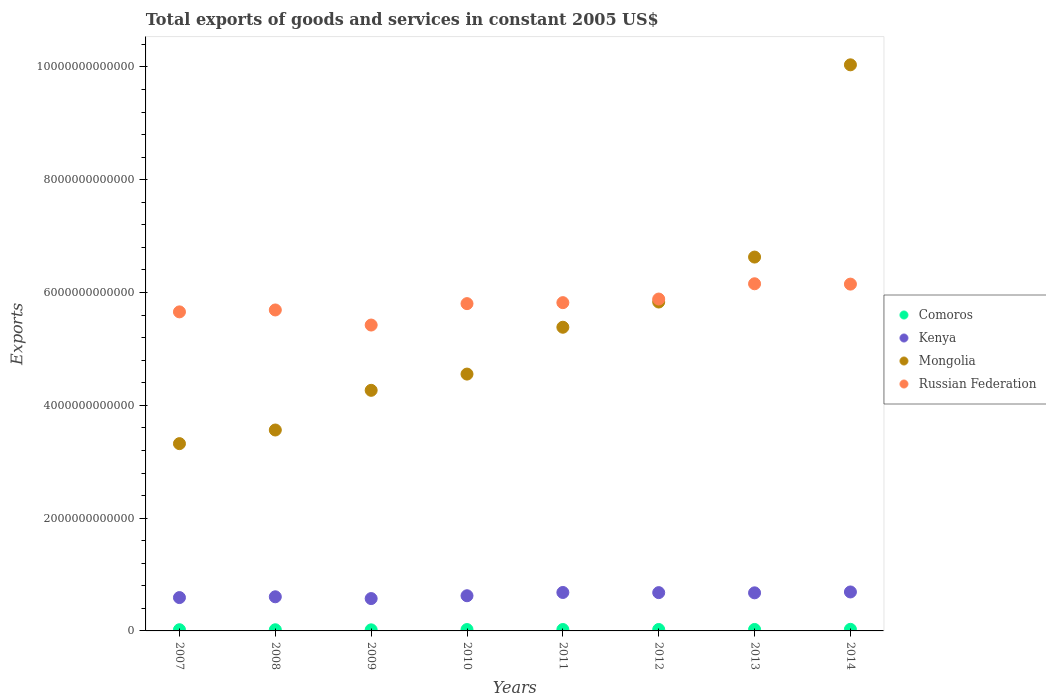What is the total exports of goods and services in Comoros in 2014?
Offer a very short reply. 2.82e+1. Across all years, what is the maximum total exports of goods and services in Comoros?
Provide a succinct answer. 2.82e+1. Across all years, what is the minimum total exports of goods and services in Mongolia?
Your response must be concise. 3.32e+12. What is the total total exports of goods and services in Kenya in the graph?
Offer a very short reply. 5.12e+12. What is the difference between the total exports of goods and services in Mongolia in 2009 and that in 2012?
Offer a very short reply. -1.57e+12. What is the difference between the total exports of goods and services in Kenya in 2008 and the total exports of goods and services in Comoros in 2009?
Keep it short and to the point. 5.86e+11. What is the average total exports of goods and services in Comoros per year?
Offer a very short reply. 2.37e+1. In the year 2010, what is the difference between the total exports of goods and services in Comoros and total exports of goods and services in Russian Federation?
Ensure brevity in your answer.  -5.78e+12. What is the ratio of the total exports of goods and services in Comoros in 2013 to that in 2014?
Your answer should be very brief. 0.92. Is the total exports of goods and services in Russian Federation in 2007 less than that in 2012?
Make the answer very short. Yes. Is the difference between the total exports of goods and services in Comoros in 2007 and 2013 greater than the difference between the total exports of goods and services in Russian Federation in 2007 and 2013?
Provide a succinct answer. Yes. What is the difference between the highest and the second highest total exports of goods and services in Kenya?
Your answer should be very brief. 9.18e+09. What is the difference between the highest and the lowest total exports of goods and services in Russian Federation?
Your response must be concise. 7.32e+11. In how many years, is the total exports of goods and services in Mongolia greater than the average total exports of goods and services in Mongolia taken over all years?
Your answer should be compact. 3. Is the sum of the total exports of goods and services in Mongolia in 2007 and 2014 greater than the maximum total exports of goods and services in Kenya across all years?
Keep it short and to the point. Yes. Is it the case that in every year, the sum of the total exports of goods and services in Kenya and total exports of goods and services in Mongolia  is greater than the total exports of goods and services in Comoros?
Make the answer very short. Yes. Is the total exports of goods and services in Mongolia strictly greater than the total exports of goods and services in Comoros over the years?
Provide a succinct answer. Yes. How many years are there in the graph?
Provide a succinct answer. 8. What is the difference between two consecutive major ticks on the Y-axis?
Offer a very short reply. 2.00e+12. Are the values on the major ticks of Y-axis written in scientific E-notation?
Make the answer very short. No. Does the graph contain grids?
Offer a terse response. No. What is the title of the graph?
Make the answer very short. Total exports of goods and services in constant 2005 US$. Does "Guinea-Bissau" appear as one of the legend labels in the graph?
Provide a short and direct response. No. What is the label or title of the X-axis?
Ensure brevity in your answer.  Years. What is the label or title of the Y-axis?
Keep it short and to the point. Exports. What is the Exports of Comoros in 2007?
Provide a short and direct response. 2.13e+1. What is the Exports of Kenya in 2007?
Your answer should be very brief. 5.91e+11. What is the Exports in Mongolia in 2007?
Give a very brief answer. 3.32e+12. What is the Exports in Russian Federation in 2007?
Your answer should be compact. 5.66e+12. What is the Exports in Comoros in 2008?
Give a very brief answer. 2.06e+1. What is the Exports in Kenya in 2008?
Provide a succinct answer. 6.05e+11. What is the Exports in Mongolia in 2008?
Your response must be concise. 3.56e+12. What is the Exports of Russian Federation in 2008?
Keep it short and to the point. 5.69e+12. What is the Exports in Comoros in 2009?
Give a very brief answer. 1.91e+1. What is the Exports in Kenya in 2009?
Make the answer very short. 5.74e+11. What is the Exports of Mongolia in 2009?
Provide a succinct answer. 4.27e+12. What is the Exports in Russian Federation in 2009?
Offer a terse response. 5.42e+12. What is the Exports of Comoros in 2010?
Your response must be concise. 2.44e+1. What is the Exports in Kenya in 2010?
Your answer should be compact. 6.24e+11. What is the Exports of Mongolia in 2010?
Give a very brief answer. 4.55e+12. What is the Exports of Russian Federation in 2010?
Give a very brief answer. 5.80e+12. What is the Exports of Comoros in 2011?
Ensure brevity in your answer.  2.48e+1. What is the Exports of Kenya in 2011?
Provide a succinct answer. 6.82e+11. What is the Exports in Mongolia in 2011?
Ensure brevity in your answer.  5.38e+12. What is the Exports of Russian Federation in 2011?
Your response must be concise. 5.82e+12. What is the Exports in Comoros in 2012?
Offer a very short reply. 2.53e+1. What is the Exports in Kenya in 2012?
Give a very brief answer. 6.79e+11. What is the Exports in Mongolia in 2012?
Keep it short and to the point. 5.83e+12. What is the Exports in Russian Federation in 2012?
Offer a very short reply. 5.88e+12. What is the Exports of Comoros in 2013?
Provide a succinct answer. 2.58e+1. What is the Exports of Kenya in 2013?
Make the answer very short. 6.75e+11. What is the Exports in Mongolia in 2013?
Your answer should be very brief. 6.63e+12. What is the Exports in Russian Federation in 2013?
Offer a terse response. 6.16e+12. What is the Exports in Comoros in 2014?
Offer a terse response. 2.82e+1. What is the Exports in Kenya in 2014?
Offer a very short reply. 6.91e+11. What is the Exports of Mongolia in 2014?
Provide a short and direct response. 1.00e+13. What is the Exports in Russian Federation in 2014?
Your answer should be compact. 6.15e+12. Across all years, what is the maximum Exports of Comoros?
Make the answer very short. 2.82e+1. Across all years, what is the maximum Exports in Kenya?
Your answer should be compact. 6.91e+11. Across all years, what is the maximum Exports of Mongolia?
Offer a terse response. 1.00e+13. Across all years, what is the maximum Exports in Russian Federation?
Your answer should be very brief. 6.16e+12. Across all years, what is the minimum Exports of Comoros?
Ensure brevity in your answer.  1.91e+1. Across all years, what is the minimum Exports in Kenya?
Provide a short and direct response. 5.74e+11. Across all years, what is the minimum Exports of Mongolia?
Your answer should be very brief. 3.32e+12. Across all years, what is the minimum Exports of Russian Federation?
Your answer should be very brief. 5.42e+12. What is the total Exports in Comoros in the graph?
Your answer should be compact. 1.90e+11. What is the total Exports of Kenya in the graph?
Your answer should be very brief. 5.12e+12. What is the total Exports in Mongolia in the graph?
Provide a short and direct response. 4.36e+13. What is the total Exports of Russian Federation in the graph?
Ensure brevity in your answer.  4.66e+13. What is the difference between the Exports of Comoros in 2007 and that in 2008?
Your answer should be very brief. 7.52e+08. What is the difference between the Exports of Kenya in 2007 and that in 2008?
Give a very brief answer. -1.40e+1. What is the difference between the Exports in Mongolia in 2007 and that in 2008?
Make the answer very short. -2.42e+11. What is the difference between the Exports of Russian Federation in 2007 and that in 2008?
Your answer should be very brief. -3.39e+1. What is the difference between the Exports of Comoros in 2007 and that in 2009?
Provide a succinct answer. 2.17e+09. What is the difference between the Exports of Kenya in 2007 and that in 2009?
Your response must be concise. 1.76e+1. What is the difference between the Exports in Mongolia in 2007 and that in 2009?
Your response must be concise. -9.45e+11. What is the difference between the Exports in Russian Federation in 2007 and that in 2009?
Your response must be concise. 2.34e+11. What is the difference between the Exports of Comoros in 2007 and that in 2010?
Keep it short and to the point. -3.05e+09. What is the difference between the Exports of Kenya in 2007 and that in 2010?
Provide a succinct answer. -3.26e+1. What is the difference between the Exports in Mongolia in 2007 and that in 2010?
Keep it short and to the point. -1.23e+12. What is the difference between the Exports in Russian Federation in 2007 and that in 2010?
Provide a short and direct response. -1.46e+11. What is the difference between the Exports of Comoros in 2007 and that in 2011?
Offer a terse response. -3.54e+09. What is the difference between the Exports in Kenya in 2007 and that in 2011?
Keep it short and to the point. -9.05e+1. What is the difference between the Exports in Mongolia in 2007 and that in 2011?
Offer a very short reply. -2.06e+12. What is the difference between the Exports of Russian Federation in 2007 and that in 2011?
Your answer should be very brief. -1.64e+11. What is the difference between the Exports in Comoros in 2007 and that in 2012?
Offer a very short reply. -4.03e+09. What is the difference between the Exports of Kenya in 2007 and that in 2012?
Make the answer very short. -8.78e+1. What is the difference between the Exports in Mongolia in 2007 and that in 2012?
Make the answer very short. -2.51e+12. What is the difference between the Exports of Russian Federation in 2007 and that in 2012?
Your response must be concise. -2.28e+11. What is the difference between the Exports in Comoros in 2007 and that in 2013?
Offer a very short reply. -4.54e+09. What is the difference between the Exports in Kenya in 2007 and that in 2013?
Your answer should be compact. -8.40e+1. What is the difference between the Exports in Mongolia in 2007 and that in 2013?
Give a very brief answer. -3.31e+12. What is the difference between the Exports of Russian Federation in 2007 and that in 2013?
Ensure brevity in your answer.  -4.98e+11. What is the difference between the Exports of Comoros in 2007 and that in 2014?
Provide a succinct answer. -6.87e+09. What is the difference between the Exports in Kenya in 2007 and that in 2014?
Offer a terse response. -9.97e+1. What is the difference between the Exports in Mongolia in 2007 and that in 2014?
Give a very brief answer. -6.72e+12. What is the difference between the Exports of Russian Federation in 2007 and that in 2014?
Offer a very short reply. -4.92e+11. What is the difference between the Exports of Comoros in 2008 and that in 2009?
Make the answer very short. 1.42e+09. What is the difference between the Exports in Kenya in 2008 and that in 2009?
Offer a very short reply. 3.16e+1. What is the difference between the Exports in Mongolia in 2008 and that in 2009?
Give a very brief answer. -7.04e+11. What is the difference between the Exports in Russian Federation in 2008 and that in 2009?
Make the answer very short. 2.67e+11. What is the difference between the Exports in Comoros in 2008 and that in 2010?
Keep it short and to the point. -3.80e+09. What is the difference between the Exports of Kenya in 2008 and that in 2010?
Your answer should be compact. -1.86e+1. What is the difference between the Exports in Mongolia in 2008 and that in 2010?
Your response must be concise. -9.92e+11. What is the difference between the Exports of Russian Federation in 2008 and that in 2010?
Provide a succinct answer. -1.12e+11. What is the difference between the Exports in Comoros in 2008 and that in 2011?
Provide a succinct answer. -4.29e+09. What is the difference between the Exports in Kenya in 2008 and that in 2011?
Your answer should be compact. -7.65e+1. What is the difference between the Exports of Mongolia in 2008 and that in 2011?
Provide a succinct answer. -1.82e+12. What is the difference between the Exports of Russian Federation in 2008 and that in 2011?
Provide a short and direct response. -1.30e+11. What is the difference between the Exports of Comoros in 2008 and that in 2012?
Ensure brevity in your answer.  -4.79e+09. What is the difference between the Exports of Kenya in 2008 and that in 2012?
Provide a short and direct response. -7.38e+1. What is the difference between the Exports of Mongolia in 2008 and that in 2012?
Offer a terse response. -2.27e+12. What is the difference between the Exports in Russian Federation in 2008 and that in 2012?
Provide a short and direct response. -1.94e+11. What is the difference between the Exports in Comoros in 2008 and that in 2013?
Keep it short and to the point. -5.29e+09. What is the difference between the Exports in Kenya in 2008 and that in 2013?
Keep it short and to the point. -7.00e+1. What is the difference between the Exports in Mongolia in 2008 and that in 2013?
Provide a short and direct response. -3.07e+12. What is the difference between the Exports of Russian Federation in 2008 and that in 2013?
Offer a very short reply. -4.64e+11. What is the difference between the Exports in Comoros in 2008 and that in 2014?
Your answer should be very brief. -7.62e+09. What is the difference between the Exports of Kenya in 2008 and that in 2014?
Offer a terse response. -8.56e+1. What is the difference between the Exports in Mongolia in 2008 and that in 2014?
Give a very brief answer. -6.48e+12. What is the difference between the Exports of Russian Federation in 2008 and that in 2014?
Your answer should be very brief. -4.58e+11. What is the difference between the Exports of Comoros in 2009 and that in 2010?
Make the answer very short. -5.22e+09. What is the difference between the Exports in Kenya in 2009 and that in 2010?
Give a very brief answer. -5.02e+1. What is the difference between the Exports of Mongolia in 2009 and that in 2010?
Provide a succinct answer. -2.88e+11. What is the difference between the Exports of Russian Federation in 2009 and that in 2010?
Your response must be concise. -3.80e+11. What is the difference between the Exports in Comoros in 2009 and that in 2011?
Provide a succinct answer. -5.71e+09. What is the difference between the Exports in Kenya in 2009 and that in 2011?
Give a very brief answer. -1.08e+11. What is the difference between the Exports of Mongolia in 2009 and that in 2011?
Your answer should be compact. -1.12e+12. What is the difference between the Exports of Russian Federation in 2009 and that in 2011?
Make the answer very short. -3.97e+11. What is the difference between the Exports in Comoros in 2009 and that in 2012?
Provide a succinct answer. -6.20e+09. What is the difference between the Exports of Kenya in 2009 and that in 2012?
Make the answer very short. -1.05e+11. What is the difference between the Exports of Mongolia in 2009 and that in 2012?
Offer a very short reply. -1.57e+12. What is the difference between the Exports of Russian Federation in 2009 and that in 2012?
Ensure brevity in your answer.  -4.61e+11. What is the difference between the Exports in Comoros in 2009 and that in 2013?
Ensure brevity in your answer.  -6.71e+09. What is the difference between the Exports in Kenya in 2009 and that in 2013?
Provide a succinct answer. -1.02e+11. What is the difference between the Exports in Mongolia in 2009 and that in 2013?
Your response must be concise. -2.36e+12. What is the difference between the Exports in Russian Federation in 2009 and that in 2013?
Ensure brevity in your answer.  -7.32e+11. What is the difference between the Exports in Comoros in 2009 and that in 2014?
Your answer should be very brief. -9.04e+09. What is the difference between the Exports of Kenya in 2009 and that in 2014?
Your answer should be very brief. -1.17e+11. What is the difference between the Exports of Mongolia in 2009 and that in 2014?
Offer a terse response. -5.77e+12. What is the difference between the Exports of Russian Federation in 2009 and that in 2014?
Offer a very short reply. -7.26e+11. What is the difference between the Exports in Comoros in 2010 and that in 2011?
Offer a terse response. -4.87e+08. What is the difference between the Exports in Kenya in 2010 and that in 2011?
Provide a short and direct response. -5.79e+1. What is the difference between the Exports of Mongolia in 2010 and that in 2011?
Provide a short and direct response. -8.30e+11. What is the difference between the Exports in Russian Federation in 2010 and that in 2011?
Offer a very short reply. -1.74e+1. What is the difference between the Exports in Comoros in 2010 and that in 2012?
Ensure brevity in your answer.  -9.84e+08. What is the difference between the Exports in Kenya in 2010 and that in 2012?
Provide a short and direct response. -5.52e+1. What is the difference between the Exports of Mongolia in 2010 and that in 2012?
Offer a terse response. -1.28e+12. What is the difference between the Exports of Russian Federation in 2010 and that in 2012?
Give a very brief answer. -8.14e+1. What is the difference between the Exports of Comoros in 2010 and that in 2013?
Your answer should be compact. -1.49e+09. What is the difference between the Exports in Kenya in 2010 and that in 2013?
Your answer should be very brief. -5.14e+1. What is the difference between the Exports in Mongolia in 2010 and that in 2013?
Provide a short and direct response. -2.07e+12. What is the difference between the Exports in Russian Federation in 2010 and that in 2013?
Your answer should be very brief. -3.52e+11. What is the difference between the Exports of Comoros in 2010 and that in 2014?
Provide a succinct answer. -3.82e+09. What is the difference between the Exports of Kenya in 2010 and that in 2014?
Offer a very short reply. -6.71e+1. What is the difference between the Exports in Mongolia in 2010 and that in 2014?
Offer a terse response. -5.48e+12. What is the difference between the Exports in Russian Federation in 2010 and that in 2014?
Your answer should be compact. -3.46e+11. What is the difference between the Exports in Comoros in 2011 and that in 2012?
Provide a short and direct response. -4.97e+08. What is the difference between the Exports in Kenya in 2011 and that in 2012?
Offer a very short reply. 2.67e+09. What is the difference between the Exports of Mongolia in 2011 and that in 2012?
Ensure brevity in your answer.  -4.47e+11. What is the difference between the Exports of Russian Federation in 2011 and that in 2012?
Your response must be concise. -6.40e+1. What is the difference between the Exports in Comoros in 2011 and that in 2013?
Ensure brevity in your answer.  -1.00e+09. What is the difference between the Exports in Kenya in 2011 and that in 2013?
Your response must be concise. 6.44e+09. What is the difference between the Exports of Mongolia in 2011 and that in 2013?
Offer a very short reply. -1.24e+12. What is the difference between the Exports of Russian Federation in 2011 and that in 2013?
Provide a succinct answer. -3.35e+11. What is the difference between the Exports of Comoros in 2011 and that in 2014?
Offer a very short reply. -3.33e+09. What is the difference between the Exports of Kenya in 2011 and that in 2014?
Keep it short and to the point. -9.18e+09. What is the difference between the Exports of Mongolia in 2011 and that in 2014?
Your response must be concise. -4.65e+12. What is the difference between the Exports of Russian Federation in 2011 and that in 2014?
Provide a short and direct response. -3.29e+11. What is the difference between the Exports in Comoros in 2012 and that in 2013?
Keep it short and to the point. -5.07e+08. What is the difference between the Exports of Kenya in 2012 and that in 2013?
Make the answer very short. 3.77e+09. What is the difference between the Exports in Mongolia in 2012 and that in 2013?
Your response must be concise. -7.97e+11. What is the difference between the Exports of Russian Federation in 2012 and that in 2013?
Offer a very short reply. -2.71e+11. What is the difference between the Exports in Comoros in 2012 and that in 2014?
Provide a short and direct response. -2.83e+09. What is the difference between the Exports in Kenya in 2012 and that in 2014?
Offer a very short reply. -1.18e+1. What is the difference between the Exports in Mongolia in 2012 and that in 2014?
Your answer should be compact. -4.21e+12. What is the difference between the Exports in Russian Federation in 2012 and that in 2014?
Ensure brevity in your answer.  -2.65e+11. What is the difference between the Exports in Comoros in 2013 and that in 2014?
Give a very brief answer. -2.33e+09. What is the difference between the Exports of Kenya in 2013 and that in 2014?
Your answer should be very brief. -1.56e+1. What is the difference between the Exports in Mongolia in 2013 and that in 2014?
Provide a short and direct response. -3.41e+12. What is the difference between the Exports in Russian Federation in 2013 and that in 2014?
Your answer should be compact. 6.16e+09. What is the difference between the Exports in Comoros in 2007 and the Exports in Kenya in 2008?
Make the answer very short. -5.84e+11. What is the difference between the Exports in Comoros in 2007 and the Exports in Mongolia in 2008?
Give a very brief answer. -3.54e+12. What is the difference between the Exports in Comoros in 2007 and the Exports in Russian Federation in 2008?
Keep it short and to the point. -5.67e+12. What is the difference between the Exports in Kenya in 2007 and the Exports in Mongolia in 2008?
Offer a terse response. -2.97e+12. What is the difference between the Exports of Kenya in 2007 and the Exports of Russian Federation in 2008?
Provide a short and direct response. -5.10e+12. What is the difference between the Exports in Mongolia in 2007 and the Exports in Russian Federation in 2008?
Offer a terse response. -2.37e+12. What is the difference between the Exports in Comoros in 2007 and the Exports in Kenya in 2009?
Make the answer very short. -5.52e+11. What is the difference between the Exports in Comoros in 2007 and the Exports in Mongolia in 2009?
Provide a short and direct response. -4.24e+12. What is the difference between the Exports of Comoros in 2007 and the Exports of Russian Federation in 2009?
Make the answer very short. -5.40e+12. What is the difference between the Exports in Kenya in 2007 and the Exports in Mongolia in 2009?
Make the answer very short. -3.68e+12. What is the difference between the Exports of Kenya in 2007 and the Exports of Russian Federation in 2009?
Give a very brief answer. -4.83e+12. What is the difference between the Exports in Mongolia in 2007 and the Exports in Russian Federation in 2009?
Offer a terse response. -2.10e+12. What is the difference between the Exports of Comoros in 2007 and the Exports of Kenya in 2010?
Your answer should be compact. -6.03e+11. What is the difference between the Exports in Comoros in 2007 and the Exports in Mongolia in 2010?
Give a very brief answer. -4.53e+12. What is the difference between the Exports of Comoros in 2007 and the Exports of Russian Federation in 2010?
Your answer should be compact. -5.78e+12. What is the difference between the Exports in Kenya in 2007 and the Exports in Mongolia in 2010?
Offer a terse response. -3.96e+12. What is the difference between the Exports of Kenya in 2007 and the Exports of Russian Federation in 2010?
Offer a very short reply. -5.21e+12. What is the difference between the Exports of Mongolia in 2007 and the Exports of Russian Federation in 2010?
Your answer should be very brief. -2.48e+12. What is the difference between the Exports in Comoros in 2007 and the Exports in Kenya in 2011?
Your answer should be very brief. -6.60e+11. What is the difference between the Exports in Comoros in 2007 and the Exports in Mongolia in 2011?
Provide a succinct answer. -5.36e+12. What is the difference between the Exports of Comoros in 2007 and the Exports of Russian Federation in 2011?
Provide a succinct answer. -5.80e+12. What is the difference between the Exports in Kenya in 2007 and the Exports in Mongolia in 2011?
Keep it short and to the point. -4.79e+12. What is the difference between the Exports in Kenya in 2007 and the Exports in Russian Federation in 2011?
Your answer should be very brief. -5.23e+12. What is the difference between the Exports in Mongolia in 2007 and the Exports in Russian Federation in 2011?
Provide a short and direct response. -2.50e+12. What is the difference between the Exports of Comoros in 2007 and the Exports of Kenya in 2012?
Make the answer very short. -6.58e+11. What is the difference between the Exports of Comoros in 2007 and the Exports of Mongolia in 2012?
Your answer should be compact. -5.81e+12. What is the difference between the Exports in Comoros in 2007 and the Exports in Russian Federation in 2012?
Make the answer very short. -5.86e+12. What is the difference between the Exports in Kenya in 2007 and the Exports in Mongolia in 2012?
Your answer should be compact. -5.24e+12. What is the difference between the Exports in Kenya in 2007 and the Exports in Russian Federation in 2012?
Offer a terse response. -5.29e+12. What is the difference between the Exports in Mongolia in 2007 and the Exports in Russian Federation in 2012?
Your answer should be very brief. -2.56e+12. What is the difference between the Exports in Comoros in 2007 and the Exports in Kenya in 2013?
Your answer should be compact. -6.54e+11. What is the difference between the Exports of Comoros in 2007 and the Exports of Mongolia in 2013?
Your answer should be compact. -6.61e+12. What is the difference between the Exports in Comoros in 2007 and the Exports in Russian Federation in 2013?
Your answer should be very brief. -6.13e+12. What is the difference between the Exports of Kenya in 2007 and the Exports of Mongolia in 2013?
Your answer should be very brief. -6.04e+12. What is the difference between the Exports of Kenya in 2007 and the Exports of Russian Federation in 2013?
Your answer should be compact. -5.56e+12. What is the difference between the Exports of Mongolia in 2007 and the Exports of Russian Federation in 2013?
Your response must be concise. -2.83e+12. What is the difference between the Exports of Comoros in 2007 and the Exports of Kenya in 2014?
Ensure brevity in your answer.  -6.70e+11. What is the difference between the Exports in Comoros in 2007 and the Exports in Mongolia in 2014?
Offer a terse response. -1.00e+13. What is the difference between the Exports in Comoros in 2007 and the Exports in Russian Federation in 2014?
Your answer should be compact. -6.13e+12. What is the difference between the Exports in Kenya in 2007 and the Exports in Mongolia in 2014?
Your answer should be very brief. -9.45e+12. What is the difference between the Exports of Kenya in 2007 and the Exports of Russian Federation in 2014?
Your answer should be compact. -5.56e+12. What is the difference between the Exports of Mongolia in 2007 and the Exports of Russian Federation in 2014?
Your answer should be compact. -2.83e+12. What is the difference between the Exports of Comoros in 2008 and the Exports of Kenya in 2009?
Give a very brief answer. -5.53e+11. What is the difference between the Exports of Comoros in 2008 and the Exports of Mongolia in 2009?
Your response must be concise. -4.25e+12. What is the difference between the Exports in Comoros in 2008 and the Exports in Russian Federation in 2009?
Ensure brevity in your answer.  -5.40e+12. What is the difference between the Exports of Kenya in 2008 and the Exports of Mongolia in 2009?
Make the answer very short. -3.66e+12. What is the difference between the Exports of Kenya in 2008 and the Exports of Russian Federation in 2009?
Ensure brevity in your answer.  -4.82e+12. What is the difference between the Exports of Mongolia in 2008 and the Exports of Russian Federation in 2009?
Keep it short and to the point. -1.86e+12. What is the difference between the Exports in Comoros in 2008 and the Exports in Kenya in 2010?
Ensure brevity in your answer.  -6.03e+11. What is the difference between the Exports in Comoros in 2008 and the Exports in Mongolia in 2010?
Your answer should be compact. -4.53e+12. What is the difference between the Exports of Comoros in 2008 and the Exports of Russian Federation in 2010?
Provide a succinct answer. -5.78e+12. What is the difference between the Exports in Kenya in 2008 and the Exports in Mongolia in 2010?
Your response must be concise. -3.95e+12. What is the difference between the Exports in Kenya in 2008 and the Exports in Russian Federation in 2010?
Your answer should be very brief. -5.20e+12. What is the difference between the Exports in Mongolia in 2008 and the Exports in Russian Federation in 2010?
Offer a very short reply. -2.24e+12. What is the difference between the Exports in Comoros in 2008 and the Exports in Kenya in 2011?
Give a very brief answer. -6.61e+11. What is the difference between the Exports in Comoros in 2008 and the Exports in Mongolia in 2011?
Provide a short and direct response. -5.36e+12. What is the difference between the Exports of Comoros in 2008 and the Exports of Russian Federation in 2011?
Your answer should be compact. -5.80e+12. What is the difference between the Exports of Kenya in 2008 and the Exports of Mongolia in 2011?
Ensure brevity in your answer.  -4.78e+12. What is the difference between the Exports of Kenya in 2008 and the Exports of Russian Federation in 2011?
Keep it short and to the point. -5.22e+12. What is the difference between the Exports in Mongolia in 2008 and the Exports in Russian Federation in 2011?
Make the answer very short. -2.26e+12. What is the difference between the Exports of Comoros in 2008 and the Exports of Kenya in 2012?
Ensure brevity in your answer.  -6.58e+11. What is the difference between the Exports in Comoros in 2008 and the Exports in Mongolia in 2012?
Ensure brevity in your answer.  -5.81e+12. What is the difference between the Exports of Comoros in 2008 and the Exports of Russian Federation in 2012?
Keep it short and to the point. -5.86e+12. What is the difference between the Exports in Kenya in 2008 and the Exports in Mongolia in 2012?
Offer a very short reply. -5.23e+12. What is the difference between the Exports in Kenya in 2008 and the Exports in Russian Federation in 2012?
Your answer should be very brief. -5.28e+12. What is the difference between the Exports of Mongolia in 2008 and the Exports of Russian Federation in 2012?
Your answer should be compact. -2.32e+12. What is the difference between the Exports of Comoros in 2008 and the Exports of Kenya in 2013?
Provide a succinct answer. -6.55e+11. What is the difference between the Exports of Comoros in 2008 and the Exports of Mongolia in 2013?
Your response must be concise. -6.61e+12. What is the difference between the Exports in Comoros in 2008 and the Exports in Russian Federation in 2013?
Give a very brief answer. -6.14e+12. What is the difference between the Exports in Kenya in 2008 and the Exports in Mongolia in 2013?
Make the answer very short. -6.02e+12. What is the difference between the Exports of Kenya in 2008 and the Exports of Russian Federation in 2013?
Provide a short and direct response. -5.55e+12. What is the difference between the Exports in Mongolia in 2008 and the Exports in Russian Federation in 2013?
Your answer should be compact. -2.59e+12. What is the difference between the Exports in Comoros in 2008 and the Exports in Kenya in 2014?
Give a very brief answer. -6.70e+11. What is the difference between the Exports of Comoros in 2008 and the Exports of Mongolia in 2014?
Your answer should be very brief. -1.00e+13. What is the difference between the Exports of Comoros in 2008 and the Exports of Russian Federation in 2014?
Your response must be concise. -6.13e+12. What is the difference between the Exports in Kenya in 2008 and the Exports in Mongolia in 2014?
Provide a succinct answer. -9.43e+12. What is the difference between the Exports in Kenya in 2008 and the Exports in Russian Federation in 2014?
Provide a succinct answer. -5.54e+12. What is the difference between the Exports of Mongolia in 2008 and the Exports of Russian Federation in 2014?
Make the answer very short. -2.59e+12. What is the difference between the Exports in Comoros in 2009 and the Exports in Kenya in 2010?
Your answer should be compact. -6.05e+11. What is the difference between the Exports of Comoros in 2009 and the Exports of Mongolia in 2010?
Give a very brief answer. -4.54e+12. What is the difference between the Exports in Comoros in 2009 and the Exports in Russian Federation in 2010?
Give a very brief answer. -5.78e+12. What is the difference between the Exports in Kenya in 2009 and the Exports in Mongolia in 2010?
Offer a very short reply. -3.98e+12. What is the difference between the Exports in Kenya in 2009 and the Exports in Russian Federation in 2010?
Give a very brief answer. -5.23e+12. What is the difference between the Exports in Mongolia in 2009 and the Exports in Russian Federation in 2010?
Your answer should be compact. -1.54e+12. What is the difference between the Exports in Comoros in 2009 and the Exports in Kenya in 2011?
Your response must be concise. -6.63e+11. What is the difference between the Exports in Comoros in 2009 and the Exports in Mongolia in 2011?
Your answer should be very brief. -5.37e+12. What is the difference between the Exports of Comoros in 2009 and the Exports of Russian Federation in 2011?
Ensure brevity in your answer.  -5.80e+12. What is the difference between the Exports in Kenya in 2009 and the Exports in Mongolia in 2011?
Provide a short and direct response. -4.81e+12. What is the difference between the Exports in Kenya in 2009 and the Exports in Russian Federation in 2011?
Offer a very short reply. -5.25e+12. What is the difference between the Exports of Mongolia in 2009 and the Exports of Russian Federation in 2011?
Your answer should be very brief. -1.55e+12. What is the difference between the Exports in Comoros in 2009 and the Exports in Kenya in 2012?
Offer a very short reply. -6.60e+11. What is the difference between the Exports of Comoros in 2009 and the Exports of Mongolia in 2012?
Keep it short and to the point. -5.81e+12. What is the difference between the Exports in Comoros in 2009 and the Exports in Russian Federation in 2012?
Your answer should be very brief. -5.87e+12. What is the difference between the Exports of Kenya in 2009 and the Exports of Mongolia in 2012?
Provide a succinct answer. -5.26e+12. What is the difference between the Exports of Kenya in 2009 and the Exports of Russian Federation in 2012?
Your response must be concise. -5.31e+12. What is the difference between the Exports of Mongolia in 2009 and the Exports of Russian Federation in 2012?
Your answer should be compact. -1.62e+12. What is the difference between the Exports in Comoros in 2009 and the Exports in Kenya in 2013?
Ensure brevity in your answer.  -6.56e+11. What is the difference between the Exports in Comoros in 2009 and the Exports in Mongolia in 2013?
Your answer should be compact. -6.61e+12. What is the difference between the Exports in Comoros in 2009 and the Exports in Russian Federation in 2013?
Provide a short and direct response. -6.14e+12. What is the difference between the Exports in Kenya in 2009 and the Exports in Mongolia in 2013?
Offer a very short reply. -6.06e+12. What is the difference between the Exports of Kenya in 2009 and the Exports of Russian Federation in 2013?
Ensure brevity in your answer.  -5.58e+12. What is the difference between the Exports of Mongolia in 2009 and the Exports of Russian Federation in 2013?
Your response must be concise. -1.89e+12. What is the difference between the Exports in Comoros in 2009 and the Exports in Kenya in 2014?
Provide a short and direct response. -6.72e+11. What is the difference between the Exports of Comoros in 2009 and the Exports of Mongolia in 2014?
Provide a succinct answer. -1.00e+13. What is the difference between the Exports of Comoros in 2009 and the Exports of Russian Federation in 2014?
Your response must be concise. -6.13e+12. What is the difference between the Exports of Kenya in 2009 and the Exports of Mongolia in 2014?
Ensure brevity in your answer.  -9.46e+12. What is the difference between the Exports in Kenya in 2009 and the Exports in Russian Federation in 2014?
Provide a short and direct response. -5.58e+12. What is the difference between the Exports of Mongolia in 2009 and the Exports of Russian Federation in 2014?
Your response must be concise. -1.88e+12. What is the difference between the Exports of Comoros in 2010 and the Exports of Kenya in 2011?
Your response must be concise. -6.57e+11. What is the difference between the Exports of Comoros in 2010 and the Exports of Mongolia in 2011?
Provide a short and direct response. -5.36e+12. What is the difference between the Exports of Comoros in 2010 and the Exports of Russian Federation in 2011?
Your response must be concise. -5.80e+12. What is the difference between the Exports of Kenya in 2010 and the Exports of Mongolia in 2011?
Offer a terse response. -4.76e+12. What is the difference between the Exports of Kenya in 2010 and the Exports of Russian Federation in 2011?
Ensure brevity in your answer.  -5.20e+12. What is the difference between the Exports in Mongolia in 2010 and the Exports in Russian Federation in 2011?
Your response must be concise. -1.27e+12. What is the difference between the Exports of Comoros in 2010 and the Exports of Kenya in 2012?
Offer a very short reply. -6.55e+11. What is the difference between the Exports of Comoros in 2010 and the Exports of Mongolia in 2012?
Make the answer very short. -5.81e+12. What is the difference between the Exports in Comoros in 2010 and the Exports in Russian Federation in 2012?
Provide a short and direct response. -5.86e+12. What is the difference between the Exports of Kenya in 2010 and the Exports of Mongolia in 2012?
Give a very brief answer. -5.21e+12. What is the difference between the Exports of Kenya in 2010 and the Exports of Russian Federation in 2012?
Your answer should be very brief. -5.26e+12. What is the difference between the Exports in Mongolia in 2010 and the Exports in Russian Federation in 2012?
Give a very brief answer. -1.33e+12. What is the difference between the Exports in Comoros in 2010 and the Exports in Kenya in 2013?
Your response must be concise. -6.51e+11. What is the difference between the Exports of Comoros in 2010 and the Exports of Mongolia in 2013?
Offer a very short reply. -6.60e+12. What is the difference between the Exports of Comoros in 2010 and the Exports of Russian Federation in 2013?
Your answer should be very brief. -6.13e+12. What is the difference between the Exports in Kenya in 2010 and the Exports in Mongolia in 2013?
Your answer should be compact. -6.01e+12. What is the difference between the Exports of Kenya in 2010 and the Exports of Russian Federation in 2013?
Provide a succinct answer. -5.53e+12. What is the difference between the Exports of Mongolia in 2010 and the Exports of Russian Federation in 2013?
Provide a short and direct response. -1.60e+12. What is the difference between the Exports of Comoros in 2010 and the Exports of Kenya in 2014?
Make the answer very short. -6.67e+11. What is the difference between the Exports of Comoros in 2010 and the Exports of Mongolia in 2014?
Offer a very short reply. -1.00e+13. What is the difference between the Exports of Comoros in 2010 and the Exports of Russian Federation in 2014?
Your answer should be very brief. -6.13e+12. What is the difference between the Exports of Kenya in 2010 and the Exports of Mongolia in 2014?
Ensure brevity in your answer.  -9.41e+12. What is the difference between the Exports in Kenya in 2010 and the Exports in Russian Federation in 2014?
Make the answer very short. -5.53e+12. What is the difference between the Exports in Mongolia in 2010 and the Exports in Russian Federation in 2014?
Give a very brief answer. -1.60e+12. What is the difference between the Exports of Comoros in 2011 and the Exports of Kenya in 2012?
Ensure brevity in your answer.  -6.54e+11. What is the difference between the Exports of Comoros in 2011 and the Exports of Mongolia in 2012?
Ensure brevity in your answer.  -5.81e+12. What is the difference between the Exports of Comoros in 2011 and the Exports of Russian Federation in 2012?
Provide a succinct answer. -5.86e+12. What is the difference between the Exports in Kenya in 2011 and the Exports in Mongolia in 2012?
Your answer should be compact. -5.15e+12. What is the difference between the Exports in Kenya in 2011 and the Exports in Russian Federation in 2012?
Give a very brief answer. -5.20e+12. What is the difference between the Exports of Mongolia in 2011 and the Exports of Russian Federation in 2012?
Ensure brevity in your answer.  -5.00e+11. What is the difference between the Exports of Comoros in 2011 and the Exports of Kenya in 2013?
Your answer should be compact. -6.50e+11. What is the difference between the Exports in Comoros in 2011 and the Exports in Mongolia in 2013?
Give a very brief answer. -6.60e+12. What is the difference between the Exports of Comoros in 2011 and the Exports of Russian Federation in 2013?
Ensure brevity in your answer.  -6.13e+12. What is the difference between the Exports in Kenya in 2011 and the Exports in Mongolia in 2013?
Give a very brief answer. -5.95e+12. What is the difference between the Exports in Kenya in 2011 and the Exports in Russian Federation in 2013?
Provide a short and direct response. -5.47e+12. What is the difference between the Exports in Mongolia in 2011 and the Exports in Russian Federation in 2013?
Give a very brief answer. -7.71e+11. What is the difference between the Exports of Comoros in 2011 and the Exports of Kenya in 2014?
Ensure brevity in your answer.  -6.66e+11. What is the difference between the Exports in Comoros in 2011 and the Exports in Mongolia in 2014?
Give a very brief answer. -1.00e+13. What is the difference between the Exports in Comoros in 2011 and the Exports in Russian Federation in 2014?
Make the answer very short. -6.12e+12. What is the difference between the Exports in Kenya in 2011 and the Exports in Mongolia in 2014?
Your answer should be very brief. -9.36e+12. What is the difference between the Exports in Kenya in 2011 and the Exports in Russian Federation in 2014?
Your answer should be compact. -5.47e+12. What is the difference between the Exports in Mongolia in 2011 and the Exports in Russian Federation in 2014?
Your answer should be compact. -7.65e+11. What is the difference between the Exports in Comoros in 2012 and the Exports in Kenya in 2013?
Make the answer very short. -6.50e+11. What is the difference between the Exports of Comoros in 2012 and the Exports of Mongolia in 2013?
Give a very brief answer. -6.60e+12. What is the difference between the Exports of Comoros in 2012 and the Exports of Russian Federation in 2013?
Keep it short and to the point. -6.13e+12. What is the difference between the Exports in Kenya in 2012 and the Exports in Mongolia in 2013?
Ensure brevity in your answer.  -5.95e+12. What is the difference between the Exports in Kenya in 2012 and the Exports in Russian Federation in 2013?
Keep it short and to the point. -5.48e+12. What is the difference between the Exports of Mongolia in 2012 and the Exports of Russian Federation in 2013?
Ensure brevity in your answer.  -3.24e+11. What is the difference between the Exports of Comoros in 2012 and the Exports of Kenya in 2014?
Your answer should be compact. -6.66e+11. What is the difference between the Exports in Comoros in 2012 and the Exports in Mongolia in 2014?
Keep it short and to the point. -1.00e+13. What is the difference between the Exports in Comoros in 2012 and the Exports in Russian Federation in 2014?
Your answer should be compact. -6.12e+12. What is the difference between the Exports in Kenya in 2012 and the Exports in Mongolia in 2014?
Keep it short and to the point. -9.36e+12. What is the difference between the Exports of Kenya in 2012 and the Exports of Russian Federation in 2014?
Your answer should be very brief. -5.47e+12. What is the difference between the Exports of Mongolia in 2012 and the Exports of Russian Federation in 2014?
Make the answer very short. -3.17e+11. What is the difference between the Exports in Comoros in 2013 and the Exports in Kenya in 2014?
Provide a succinct answer. -6.65e+11. What is the difference between the Exports of Comoros in 2013 and the Exports of Mongolia in 2014?
Your answer should be very brief. -1.00e+13. What is the difference between the Exports in Comoros in 2013 and the Exports in Russian Federation in 2014?
Ensure brevity in your answer.  -6.12e+12. What is the difference between the Exports of Kenya in 2013 and the Exports of Mongolia in 2014?
Your answer should be compact. -9.36e+12. What is the difference between the Exports of Kenya in 2013 and the Exports of Russian Federation in 2014?
Your answer should be compact. -5.47e+12. What is the difference between the Exports of Mongolia in 2013 and the Exports of Russian Federation in 2014?
Offer a very short reply. 4.80e+11. What is the average Exports of Comoros per year?
Keep it short and to the point. 2.37e+1. What is the average Exports in Kenya per year?
Ensure brevity in your answer.  6.40e+11. What is the average Exports in Mongolia per year?
Provide a succinct answer. 5.45e+12. What is the average Exports of Russian Federation per year?
Provide a short and direct response. 5.82e+12. In the year 2007, what is the difference between the Exports in Comoros and Exports in Kenya?
Provide a short and direct response. -5.70e+11. In the year 2007, what is the difference between the Exports in Comoros and Exports in Mongolia?
Your answer should be very brief. -3.30e+12. In the year 2007, what is the difference between the Exports in Comoros and Exports in Russian Federation?
Keep it short and to the point. -5.64e+12. In the year 2007, what is the difference between the Exports of Kenya and Exports of Mongolia?
Your answer should be compact. -2.73e+12. In the year 2007, what is the difference between the Exports in Kenya and Exports in Russian Federation?
Your response must be concise. -5.07e+12. In the year 2007, what is the difference between the Exports of Mongolia and Exports of Russian Federation?
Your response must be concise. -2.34e+12. In the year 2008, what is the difference between the Exports of Comoros and Exports of Kenya?
Make the answer very short. -5.85e+11. In the year 2008, what is the difference between the Exports in Comoros and Exports in Mongolia?
Make the answer very short. -3.54e+12. In the year 2008, what is the difference between the Exports in Comoros and Exports in Russian Federation?
Give a very brief answer. -5.67e+12. In the year 2008, what is the difference between the Exports in Kenya and Exports in Mongolia?
Offer a very short reply. -2.96e+12. In the year 2008, what is the difference between the Exports of Kenya and Exports of Russian Federation?
Offer a terse response. -5.09e+12. In the year 2008, what is the difference between the Exports in Mongolia and Exports in Russian Federation?
Your answer should be compact. -2.13e+12. In the year 2009, what is the difference between the Exports of Comoros and Exports of Kenya?
Give a very brief answer. -5.55e+11. In the year 2009, what is the difference between the Exports of Comoros and Exports of Mongolia?
Offer a very short reply. -4.25e+12. In the year 2009, what is the difference between the Exports in Comoros and Exports in Russian Federation?
Give a very brief answer. -5.40e+12. In the year 2009, what is the difference between the Exports in Kenya and Exports in Mongolia?
Your answer should be very brief. -3.69e+12. In the year 2009, what is the difference between the Exports of Kenya and Exports of Russian Federation?
Ensure brevity in your answer.  -4.85e+12. In the year 2009, what is the difference between the Exports of Mongolia and Exports of Russian Federation?
Keep it short and to the point. -1.16e+12. In the year 2010, what is the difference between the Exports in Comoros and Exports in Kenya?
Offer a terse response. -5.99e+11. In the year 2010, what is the difference between the Exports in Comoros and Exports in Mongolia?
Provide a succinct answer. -4.53e+12. In the year 2010, what is the difference between the Exports of Comoros and Exports of Russian Federation?
Provide a succinct answer. -5.78e+12. In the year 2010, what is the difference between the Exports of Kenya and Exports of Mongolia?
Provide a succinct answer. -3.93e+12. In the year 2010, what is the difference between the Exports of Kenya and Exports of Russian Federation?
Keep it short and to the point. -5.18e+12. In the year 2010, what is the difference between the Exports in Mongolia and Exports in Russian Federation?
Offer a terse response. -1.25e+12. In the year 2011, what is the difference between the Exports in Comoros and Exports in Kenya?
Provide a short and direct response. -6.57e+11. In the year 2011, what is the difference between the Exports of Comoros and Exports of Mongolia?
Offer a very short reply. -5.36e+12. In the year 2011, what is the difference between the Exports in Comoros and Exports in Russian Federation?
Your answer should be very brief. -5.80e+12. In the year 2011, what is the difference between the Exports of Kenya and Exports of Mongolia?
Provide a short and direct response. -4.70e+12. In the year 2011, what is the difference between the Exports in Kenya and Exports in Russian Federation?
Provide a succinct answer. -5.14e+12. In the year 2011, what is the difference between the Exports of Mongolia and Exports of Russian Federation?
Offer a very short reply. -4.36e+11. In the year 2012, what is the difference between the Exports of Comoros and Exports of Kenya?
Your answer should be very brief. -6.54e+11. In the year 2012, what is the difference between the Exports of Comoros and Exports of Mongolia?
Keep it short and to the point. -5.81e+12. In the year 2012, what is the difference between the Exports in Comoros and Exports in Russian Federation?
Give a very brief answer. -5.86e+12. In the year 2012, what is the difference between the Exports of Kenya and Exports of Mongolia?
Provide a succinct answer. -5.15e+12. In the year 2012, what is the difference between the Exports in Kenya and Exports in Russian Federation?
Provide a succinct answer. -5.21e+12. In the year 2012, what is the difference between the Exports of Mongolia and Exports of Russian Federation?
Your answer should be compact. -5.29e+1. In the year 2013, what is the difference between the Exports in Comoros and Exports in Kenya?
Offer a very short reply. -6.49e+11. In the year 2013, what is the difference between the Exports in Comoros and Exports in Mongolia?
Your answer should be compact. -6.60e+12. In the year 2013, what is the difference between the Exports in Comoros and Exports in Russian Federation?
Offer a terse response. -6.13e+12. In the year 2013, what is the difference between the Exports of Kenya and Exports of Mongolia?
Provide a short and direct response. -5.95e+12. In the year 2013, what is the difference between the Exports in Kenya and Exports in Russian Federation?
Offer a terse response. -5.48e+12. In the year 2013, what is the difference between the Exports of Mongolia and Exports of Russian Federation?
Ensure brevity in your answer.  4.74e+11. In the year 2014, what is the difference between the Exports in Comoros and Exports in Kenya?
Provide a succinct answer. -6.63e+11. In the year 2014, what is the difference between the Exports in Comoros and Exports in Mongolia?
Your answer should be very brief. -1.00e+13. In the year 2014, what is the difference between the Exports of Comoros and Exports of Russian Federation?
Make the answer very short. -6.12e+12. In the year 2014, what is the difference between the Exports of Kenya and Exports of Mongolia?
Offer a very short reply. -9.35e+12. In the year 2014, what is the difference between the Exports of Kenya and Exports of Russian Federation?
Offer a very short reply. -5.46e+12. In the year 2014, what is the difference between the Exports of Mongolia and Exports of Russian Federation?
Keep it short and to the point. 3.89e+12. What is the ratio of the Exports of Comoros in 2007 to that in 2008?
Your answer should be very brief. 1.04. What is the ratio of the Exports of Kenya in 2007 to that in 2008?
Make the answer very short. 0.98. What is the ratio of the Exports in Mongolia in 2007 to that in 2008?
Your response must be concise. 0.93. What is the ratio of the Exports of Russian Federation in 2007 to that in 2008?
Your response must be concise. 0.99. What is the ratio of the Exports in Comoros in 2007 to that in 2009?
Provide a succinct answer. 1.11. What is the ratio of the Exports in Kenya in 2007 to that in 2009?
Provide a succinct answer. 1.03. What is the ratio of the Exports of Mongolia in 2007 to that in 2009?
Provide a succinct answer. 0.78. What is the ratio of the Exports of Russian Federation in 2007 to that in 2009?
Ensure brevity in your answer.  1.04. What is the ratio of the Exports of Comoros in 2007 to that in 2010?
Keep it short and to the point. 0.87. What is the ratio of the Exports in Kenya in 2007 to that in 2010?
Make the answer very short. 0.95. What is the ratio of the Exports of Mongolia in 2007 to that in 2010?
Offer a terse response. 0.73. What is the ratio of the Exports in Russian Federation in 2007 to that in 2010?
Make the answer very short. 0.97. What is the ratio of the Exports of Comoros in 2007 to that in 2011?
Provide a succinct answer. 0.86. What is the ratio of the Exports in Kenya in 2007 to that in 2011?
Your answer should be very brief. 0.87. What is the ratio of the Exports of Mongolia in 2007 to that in 2011?
Keep it short and to the point. 0.62. What is the ratio of the Exports of Russian Federation in 2007 to that in 2011?
Your response must be concise. 0.97. What is the ratio of the Exports of Comoros in 2007 to that in 2012?
Keep it short and to the point. 0.84. What is the ratio of the Exports in Kenya in 2007 to that in 2012?
Give a very brief answer. 0.87. What is the ratio of the Exports of Mongolia in 2007 to that in 2012?
Your answer should be very brief. 0.57. What is the ratio of the Exports of Russian Federation in 2007 to that in 2012?
Keep it short and to the point. 0.96. What is the ratio of the Exports in Comoros in 2007 to that in 2013?
Provide a succinct answer. 0.82. What is the ratio of the Exports of Kenya in 2007 to that in 2013?
Make the answer very short. 0.88. What is the ratio of the Exports in Mongolia in 2007 to that in 2013?
Provide a succinct answer. 0.5. What is the ratio of the Exports in Russian Federation in 2007 to that in 2013?
Keep it short and to the point. 0.92. What is the ratio of the Exports of Comoros in 2007 to that in 2014?
Your answer should be very brief. 0.76. What is the ratio of the Exports of Kenya in 2007 to that in 2014?
Your response must be concise. 0.86. What is the ratio of the Exports of Mongolia in 2007 to that in 2014?
Offer a terse response. 0.33. What is the ratio of the Exports in Comoros in 2008 to that in 2009?
Offer a very short reply. 1.07. What is the ratio of the Exports in Kenya in 2008 to that in 2009?
Make the answer very short. 1.06. What is the ratio of the Exports in Mongolia in 2008 to that in 2009?
Give a very brief answer. 0.84. What is the ratio of the Exports in Russian Federation in 2008 to that in 2009?
Your answer should be very brief. 1.05. What is the ratio of the Exports in Comoros in 2008 to that in 2010?
Ensure brevity in your answer.  0.84. What is the ratio of the Exports in Kenya in 2008 to that in 2010?
Provide a short and direct response. 0.97. What is the ratio of the Exports of Mongolia in 2008 to that in 2010?
Keep it short and to the point. 0.78. What is the ratio of the Exports in Russian Federation in 2008 to that in 2010?
Your answer should be compact. 0.98. What is the ratio of the Exports of Comoros in 2008 to that in 2011?
Provide a short and direct response. 0.83. What is the ratio of the Exports in Kenya in 2008 to that in 2011?
Make the answer very short. 0.89. What is the ratio of the Exports in Mongolia in 2008 to that in 2011?
Keep it short and to the point. 0.66. What is the ratio of the Exports of Russian Federation in 2008 to that in 2011?
Your response must be concise. 0.98. What is the ratio of the Exports in Comoros in 2008 to that in 2012?
Give a very brief answer. 0.81. What is the ratio of the Exports in Kenya in 2008 to that in 2012?
Offer a terse response. 0.89. What is the ratio of the Exports in Mongolia in 2008 to that in 2012?
Your response must be concise. 0.61. What is the ratio of the Exports in Russian Federation in 2008 to that in 2012?
Provide a succinct answer. 0.97. What is the ratio of the Exports of Comoros in 2008 to that in 2013?
Provide a short and direct response. 0.8. What is the ratio of the Exports of Kenya in 2008 to that in 2013?
Give a very brief answer. 0.9. What is the ratio of the Exports of Mongolia in 2008 to that in 2013?
Your answer should be compact. 0.54. What is the ratio of the Exports in Russian Federation in 2008 to that in 2013?
Provide a short and direct response. 0.92. What is the ratio of the Exports of Comoros in 2008 to that in 2014?
Ensure brevity in your answer.  0.73. What is the ratio of the Exports of Kenya in 2008 to that in 2014?
Ensure brevity in your answer.  0.88. What is the ratio of the Exports of Mongolia in 2008 to that in 2014?
Your answer should be compact. 0.35. What is the ratio of the Exports in Russian Federation in 2008 to that in 2014?
Make the answer very short. 0.93. What is the ratio of the Exports in Comoros in 2009 to that in 2010?
Provide a succinct answer. 0.79. What is the ratio of the Exports in Kenya in 2009 to that in 2010?
Keep it short and to the point. 0.92. What is the ratio of the Exports in Mongolia in 2009 to that in 2010?
Provide a succinct answer. 0.94. What is the ratio of the Exports of Russian Federation in 2009 to that in 2010?
Offer a terse response. 0.93. What is the ratio of the Exports of Comoros in 2009 to that in 2011?
Provide a short and direct response. 0.77. What is the ratio of the Exports of Kenya in 2009 to that in 2011?
Your answer should be compact. 0.84. What is the ratio of the Exports in Mongolia in 2009 to that in 2011?
Offer a terse response. 0.79. What is the ratio of the Exports of Russian Federation in 2009 to that in 2011?
Offer a very short reply. 0.93. What is the ratio of the Exports of Comoros in 2009 to that in 2012?
Make the answer very short. 0.76. What is the ratio of the Exports in Kenya in 2009 to that in 2012?
Your answer should be compact. 0.84. What is the ratio of the Exports in Mongolia in 2009 to that in 2012?
Provide a succinct answer. 0.73. What is the ratio of the Exports in Russian Federation in 2009 to that in 2012?
Make the answer very short. 0.92. What is the ratio of the Exports in Comoros in 2009 to that in 2013?
Make the answer very short. 0.74. What is the ratio of the Exports in Kenya in 2009 to that in 2013?
Provide a short and direct response. 0.85. What is the ratio of the Exports in Mongolia in 2009 to that in 2013?
Keep it short and to the point. 0.64. What is the ratio of the Exports of Russian Federation in 2009 to that in 2013?
Keep it short and to the point. 0.88. What is the ratio of the Exports of Comoros in 2009 to that in 2014?
Your answer should be compact. 0.68. What is the ratio of the Exports of Kenya in 2009 to that in 2014?
Keep it short and to the point. 0.83. What is the ratio of the Exports in Mongolia in 2009 to that in 2014?
Your answer should be compact. 0.42. What is the ratio of the Exports in Russian Federation in 2009 to that in 2014?
Provide a short and direct response. 0.88. What is the ratio of the Exports in Comoros in 2010 to that in 2011?
Provide a succinct answer. 0.98. What is the ratio of the Exports in Kenya in 2010 to that in 2011?
Ensure brevity in your answer.  0.92. What is the ratio of the Exports of Mongolia in 2010 to that in 2011?
Ensure brevity in your answer.  0.85. What is the ratio of the Exports of Russian Federation in 2010 to that in 2011?
Keep it short and to the point. 1. What is the ratio of the Exports in Comoros in 2010 to that in 2012?
Ensure brevity in your answer.  0.96. What is the ratio of the Exports of Kenya in 2010 to that in 2012?
Make the answer very short. 0.92. What is the ratio of the Exports of Mongolia in 2010 to that in 2012?
Your answer should be very brief. 0.78. What is the ratio of the Exports in Russian Federation in 2010 to that in 2012?
Your answer should be compact. 0.99. What is the ratio of the Exports of Comoros in 2010 to that in 2013?
Ensure brevity in your answer.  0.94. What is the ratio of the Exports of Kenya in 2010 to that in 2013?
Provide a succinct answer. 0.92. What is the ratio of the Exports of Mongolia in 2010 to that in 2013?
Provide a short and direct response. 0.69. What is the ratio of the Exports in Russian Federation in 2010 to that in 2013?
Your response must be concise. 0.94. What is the ratio of the Exports in Comoros in 2010 to that in 2014?
Your response must be concise. 0.86. What is the ratio of the Exports of Kenya in 2010 to that in 2014?
Provide a short and direct response. 0.9. What is the ratio of the Exports in Mongolia in 2010 to that in 2014?
Your response must be concise. 0.45. What is the ratio of the Exports in Russian Federation in 2010 to that in 2014?
Ensure brevity in your answer.  0.94. What is the ratio of the Exports of Comoros in 2011 to that in 2012?
Give a very brief answer. 0.98. What is the ratio of the Exports of Kenya in 2011 to that in 2012?
Make the answer very short. 1. What is the ratio of the Exports in Mongolia in 2011 to that in 2012?
Ensure brevity in your answer.  0.92. What is the ratio of the Exports in Russian Federation in 2011 to that in 2012?
Offer a terse response. 0.99. What is the ratio of the Exports of Comoros in 2011 to that in 2013?
Make the answer very short. 0.96. What is the ratio of the Exports in Kenya in 2011 to that in 2013?
Ensure brevity in your answer.  1.01. What is the ratio of the Exports in Mongolia in 2011 to that in 2013?
Your response must be concise. 0.81. What is the ratio of the Exports of Russian Federation in 2011 to that in 2013?
Provide a succinct answer. 0.95. What is the ratio of the Exports of Comoros in 2011 to that in 2014?
Keep it short and to the point. 0.88. What is the ratio of the Exports of Kenya in 2011 to that in 2014?
Make the answer very short. 0.99. What is the ratio of the Exports of Mongolia in 2011 to that in 2014?
Your answer should be very brief. 0.54. What is the ratio of the Exports of Russian Federation in 2011 to that in 2014?
Your answer should be very brief. 0.95. What is the ratio of the Exports of Comoros in 2012 to that in 2013?
Your response must be concise. 0.98. What is the ratio of the Exports in Kenya in 2012 to that in 2013?
Your response must be concise. 1.01. What is the ratio of the Exports of Mongolia in 2012 to that in 2013?
Provide a succinct answer. 0.88. What is the ratio of the Exports in Russian Federation in 2012 to that in 2013?
Your answer should be very brief. 0.96. What is the ratio of the Exports of Comoros in 2012 to that in 2014?
Provide a short and direct response. 0.9. What is the ratio of the Exports of Kenya in 2012 to that in 2014?
Make the answer very short. 0.98. What is the ratio of the Exports of Mongolia in 2012 to that in 2014?
Offer a terse response. 0.58. What is the ratio of the Exports of Russian Federation in 2012 to that in 2014?
Provide a short and direct response. 0.96. What is the ratio of the Exports in Comoros in 2013 to that in 2014?
Provide a short and direct response. 0.92. What is the ratio of the Exports in Kenya in 2013 to that in 2014?
Provide a short and direct response. 0.98. What is the ratio of the Exports of Mongolia in 2013 to that in 2014?
Give a very brief answer. 0.66. What is the difference between the highest and the second highest Exports of Comoros?
Offer a terse response. 2.33e+09. What is the difference between the highest and the second highest Exports of Kenya?
Offer a very short reply. 9.18e+09. What is the difference between the highest and the second highest Exports of Mongolia?
Keep it short and to the point. 3.41e+12. What is the difference between the highest and the second highest Exports in Russian Federation?
Offer a very short reply. 6.16e+09. What is the difference between the highest and the lowest Exports of Comoros?
Keep it short and to the point. 9.04e+09. What is the difference between the highest and the lowest Exports in Kenya?
Give a very brief answer. 1.17e+11. What is the difference between the highest and the lowest Exports of Mongolia?
Give a very brief answer. 6.72e+12. What is the difference between the highest and the lowest Exports in Russian Federation?
Provide a short and direct response. 7.32e+11. 